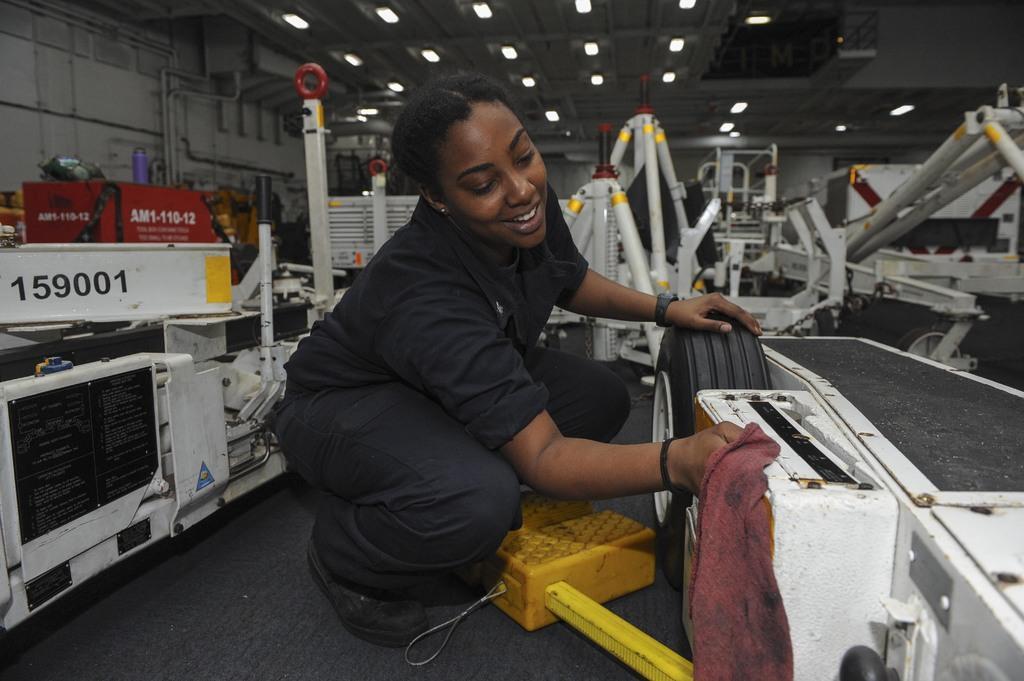Please provide a concise description of this image. In the center of the image we can see a lady, She is holding a cloth and cleaning a vehicle. In the background we can see vehicles. At the top there are lights. 